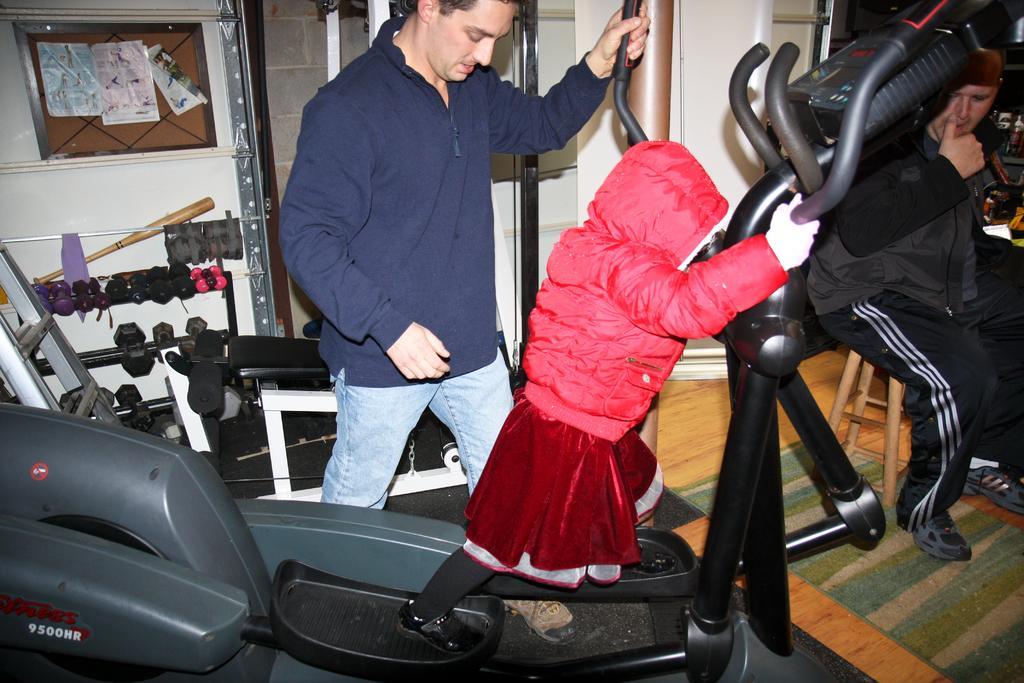Describe this image in one or two sentences. In this image we can see a child standing on an indoor cycling bike. We can also see a man standing beside her holding its handle. On the right side we can see a person sitting on a stool. On the left side we can see a board with some papers pinned to hit, a baseball bat, some dumbbells placed on the racks, a ladder and a pole. 